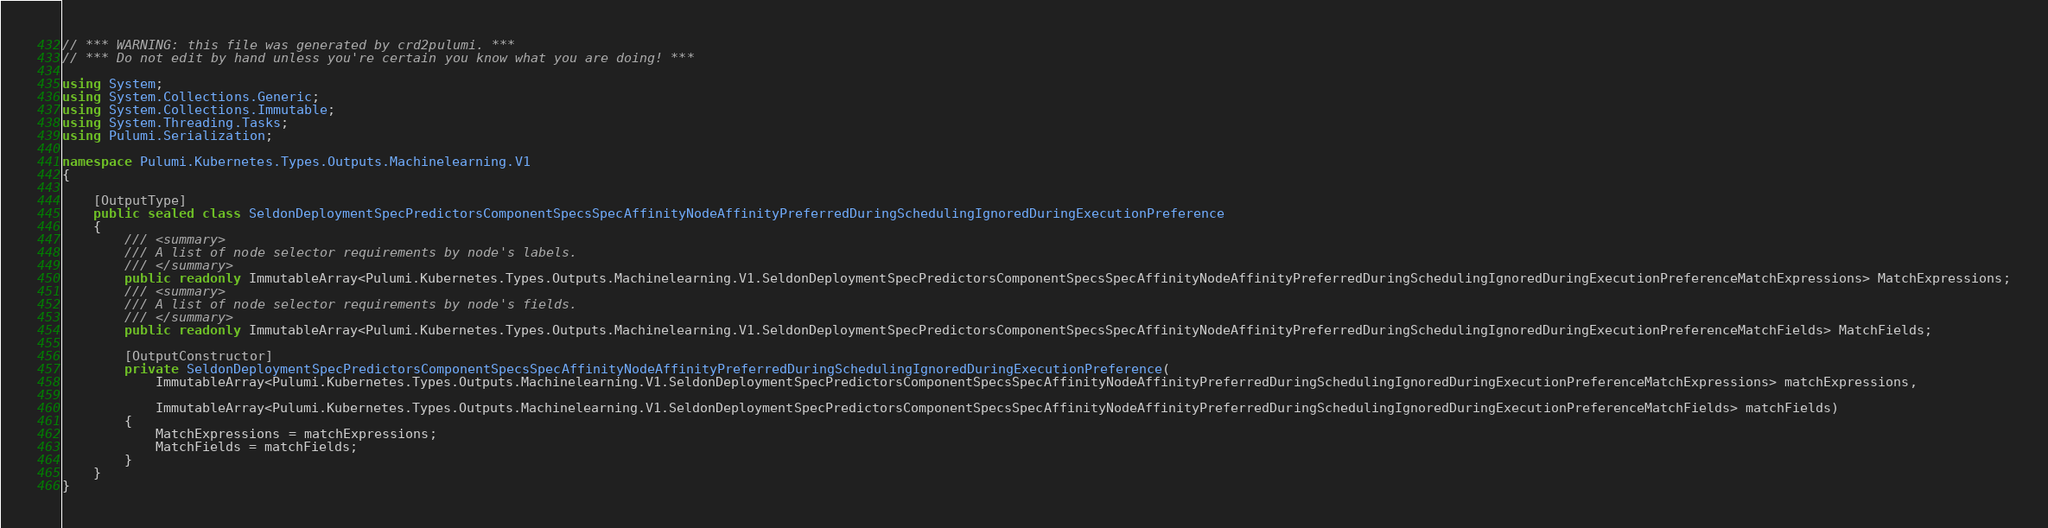<code> <loc_0><loc_0><loc_500><loc_500><_C#_>// *** WARNING: this file was generated by crd2pulumi. ***
// *** Do not edit by hand unless you're certain you know what you are doing! ***

using System;
using System.Collections.Generic;
using System.Collections.Immutable;
using System.Threading.Tasks;
using Pulumi.Serialization;

namespace Pulumi.Kubernetes.Types.Outputs.Machinelearning.V1
{

    [OutputType]
    public sealed class SeldonDeploymentSpecPredictorsComponentSpecsSpecAffinityNodeAffinityPreferredDuringSchedulingIgnoredDuringExecutionPreference
    {
        /// <summary>
        /// A list of node selector requirements by node's labels.
        /// </summary>
        public readonly ImmutableArray<Pulumi.Kubernetes.Types.Outputs.Machinelearning.V1.SeldonDeploymentSpecPredictorsComponentSpecsSpecAffinityNodeAffinityPreferredDuringSchedulingIgnoredDuringExecutionPreferenceMatchExpressions> MatchExpressions;
        /// <summary>
        /// A list of node selector requirements by node's fields.
        /// </summary>
        public readonly ImmutableArray<Pulumi.Kubernetes.Types.Outputs.Machinelearning.V1.SeldonDeploymentSpecPredictorsComponentSpecsSpecAffinityNodeAffinityPreferredDuringSchedulingIgnoredDuringExecutionPreferenceMatchFields> MatchFields;

        [OutputConstructor]
        private SeldonDeploymentSpecPredictorsComponentSpecsSpecAffinityNodeAffinityPreferredDuringSchedulingIgnoredDuringExecutionPreference(
            ImmutableArray<Pulumi.Kubernetes.Types.Outputs.Machinelearning.V1.SeldonDeploymentSpecPredictorsComponentSpecsSpecAffinityNodeAffinityPreferredDuringSchedulingIgnoredDuringExecutionPreferenceMatchExpressions> matchExpressions,

            ImmutableArray<Pulumi.Kubernetes.Types.Outputs.Machinelearning.V1.SeldonDeploymentSpecPredictorsComponentSpecsSpecAffinityNodeAffinityPreferredDuringSchedulingIgnoredDuringExecutionPreferenceMatchFields> matchFields)
        {
            MatchExpressions = matchExpressions;
            MatchFields = matchFields;
        }
    }
}
</code> 